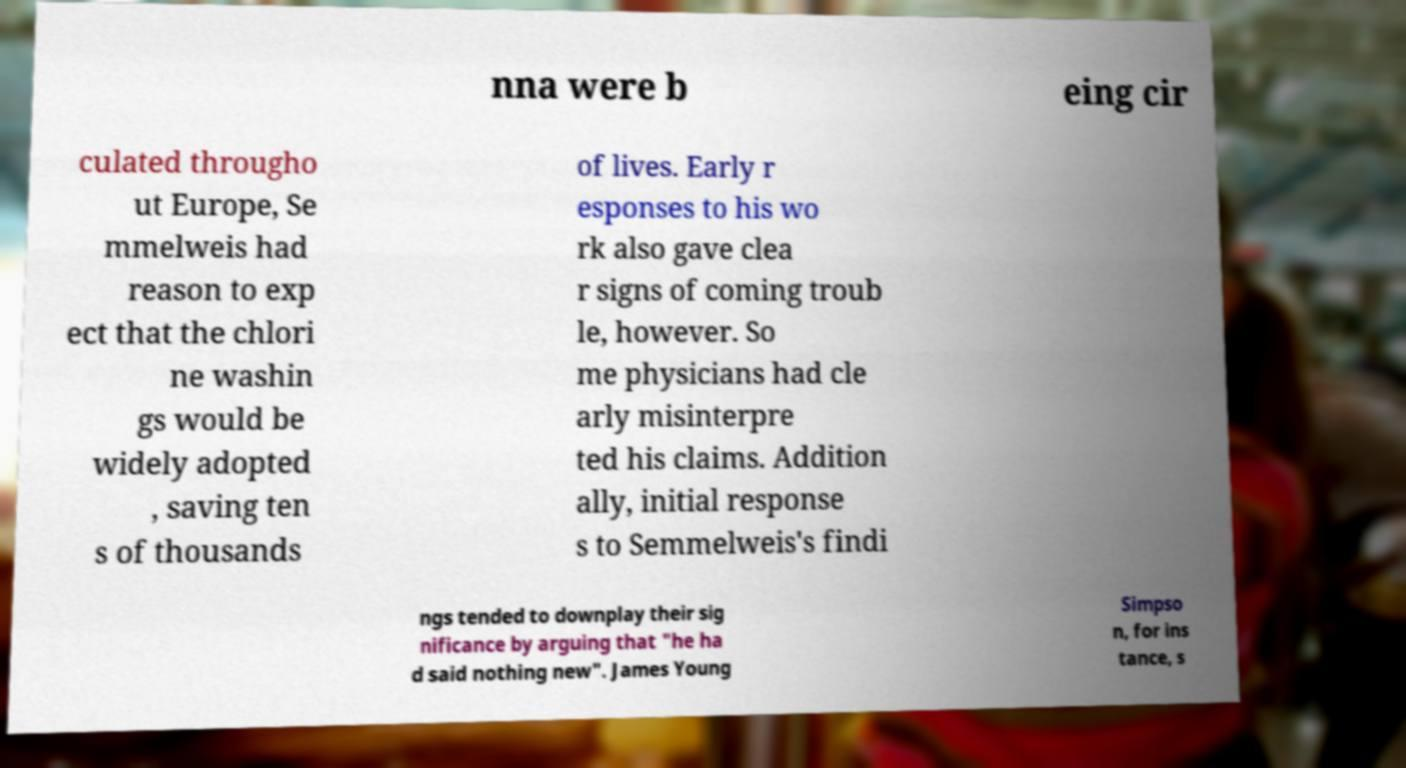Can you read and provide the text displayed in the image?This photo seems to have some interesting text. Can you extract and type it out for me? nna were b eing cir culated througho ut Europe, Se mmelweis had reason to exp ect that the chlori ne washin gs would be widely adopted , saving ten s of thousands of lives. Early r esponses to his wo rk also gave clea r signs of coming troub le, however. So me physicians had cle arly misinterpre ted his claims. Addition ally, initial response s to Semmelweis's findi ngs tended to downplay their sig nificance by arguing that "he ha d said nothing new". James Young Simpso n, for ins tance, s 